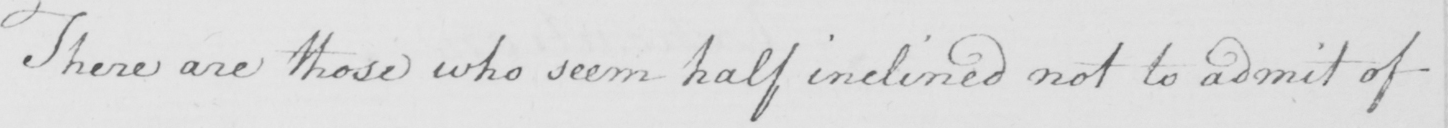What is written in this line of handwriting? There are those who seem half inclined not to admit of 